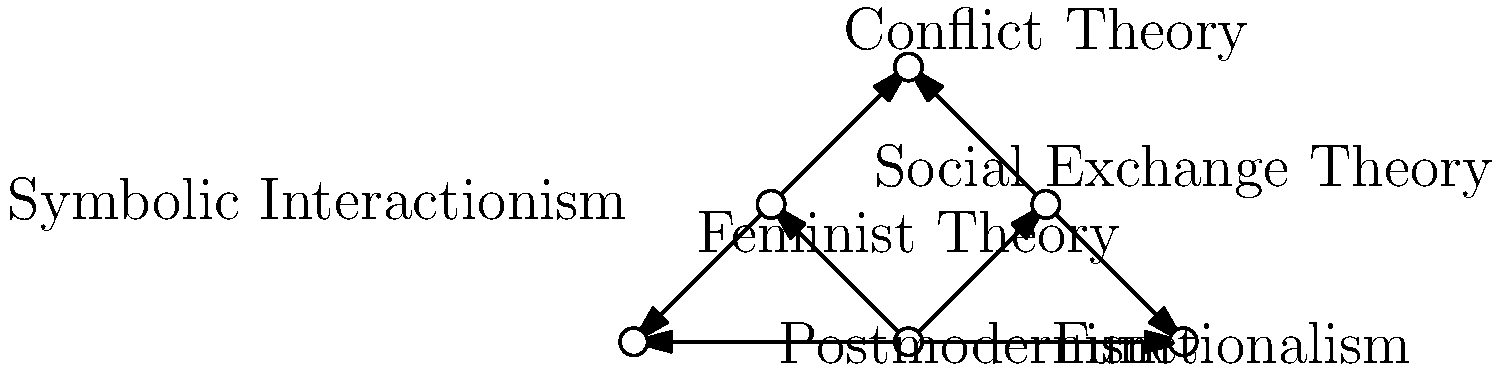In this network graph of sociological theories, which theory appears to be most central, having direct connections to all other theories except one? To determine the most central theory in this network graph, we need to analyze the connections of each node:

1. Functionalism: Located at the center, it has direct connections to all other theories except Feminist Theory.
2. Conflict Theory: Connected to Functionalism, Feminist Theory, and Social Exchange Theory.
3. Symbolic Interactionism: Connected to Functionalism, Feminist Theory, and Postmodernism.
4. Feminist Theory: Connected to Conflict Theory and Symbolic Interactionism.
5. Postmodernism: Connected to Functionalism and Symbolic Interactionism.
6. Social Exchange Theory: Connected to Functionalism and Conflict Theory.

By examining these connections, we can see that Functionalism has the most direct connections, linking to all other theories except Feminist Theory. This makes Functionalism the most central theory in the network graph.
Answer: Functionalism 